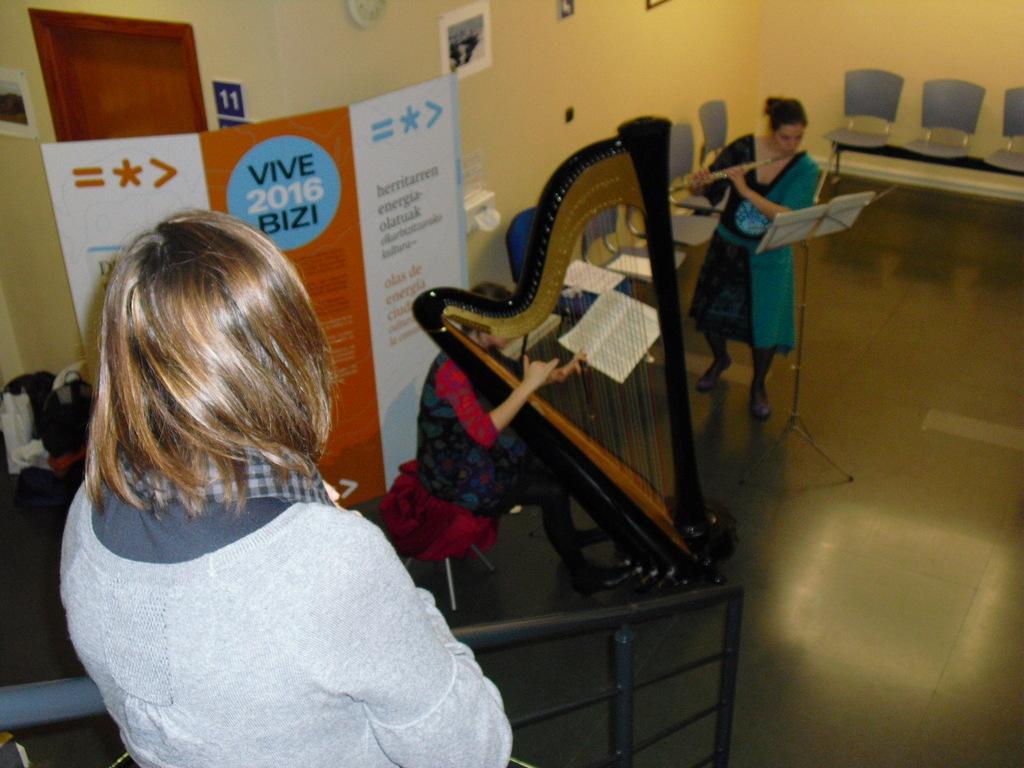Please provide a concise description of this image. As we can see in the image there is a banner and yellow color wall. There are photo frames, few people, books and chairs. These two are playing musical instruments. 